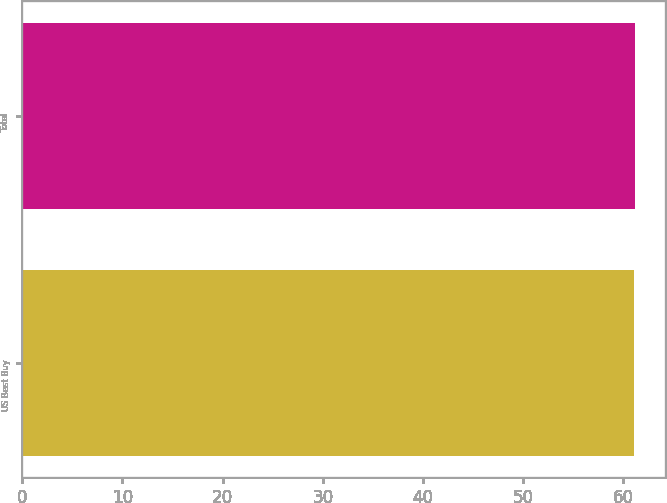<chart> <loc_0><loc_0><loc_500><loc_500><bar_chart><fcel>US Best Buy<fcel>Total<nl><fcel>61<fcel>61.1<nl></chart> 